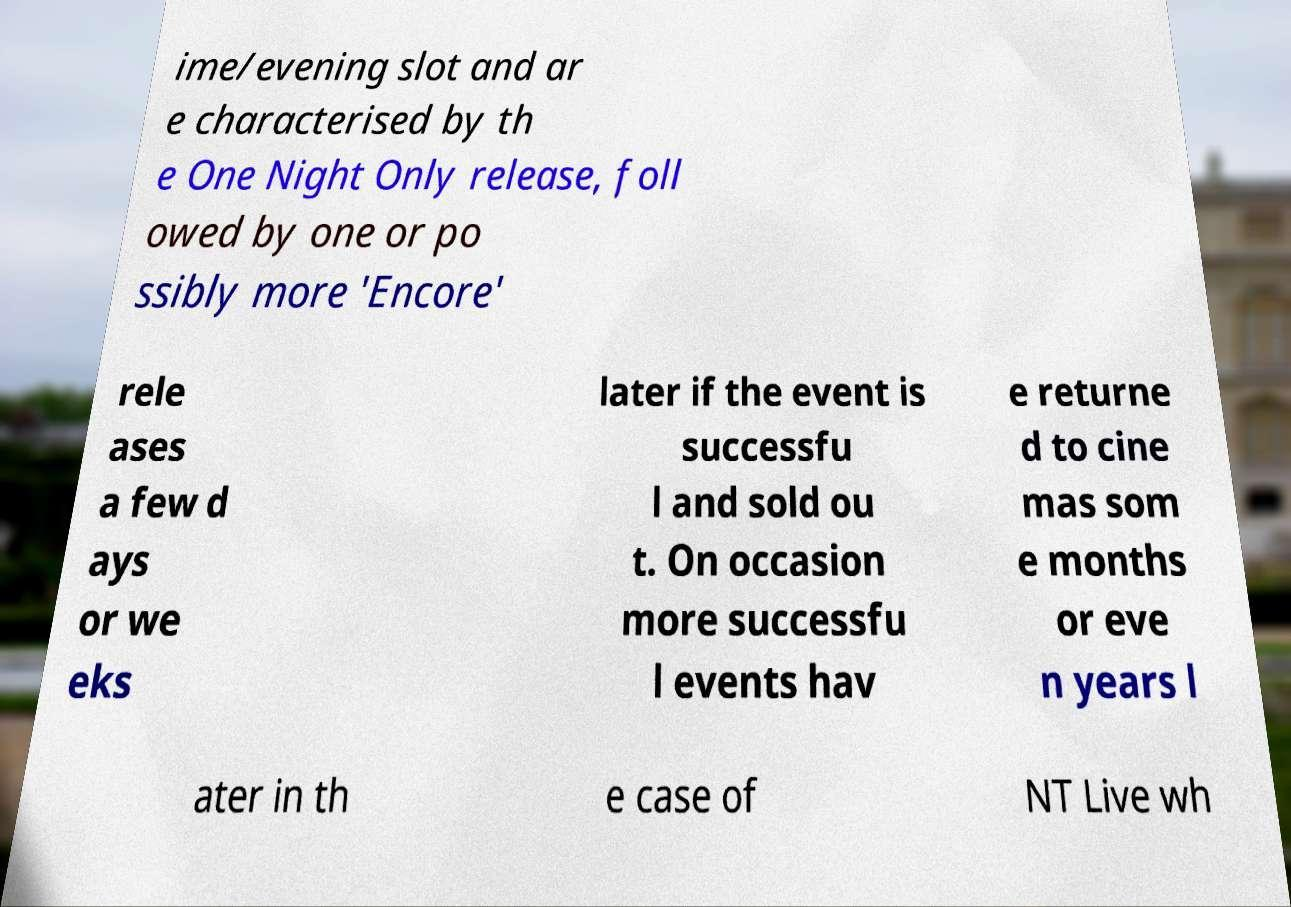For documentation purposes, I need the text within this image transcribed. Could you provide that? ime/evening slot and ar e characterised by th e One Night Only release, foll owed by one or po ssibly more 'Encore' rele ases a few d ays or we eks later if the event is successfu l and sold ou t. On occasion more successfu l events hav e returne d to cine mas som e months or eve n years l ater in th e case of NT Live wh 